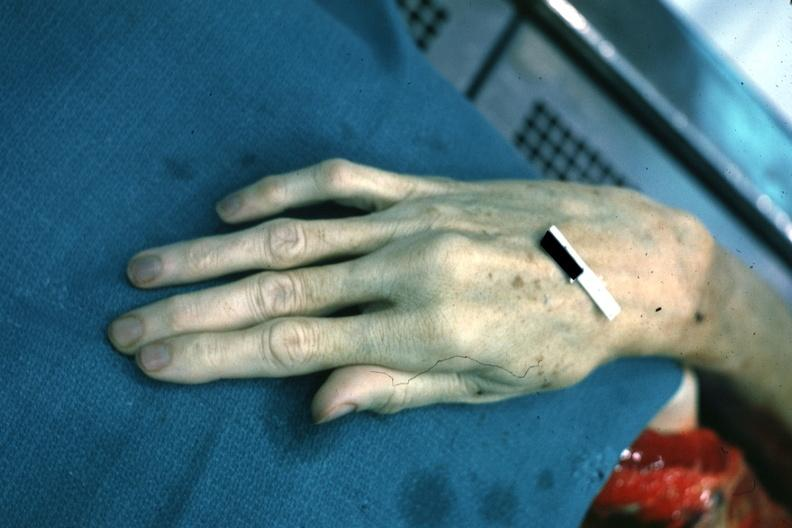s extremities present?
Answer the question using a single word or phrase. No 